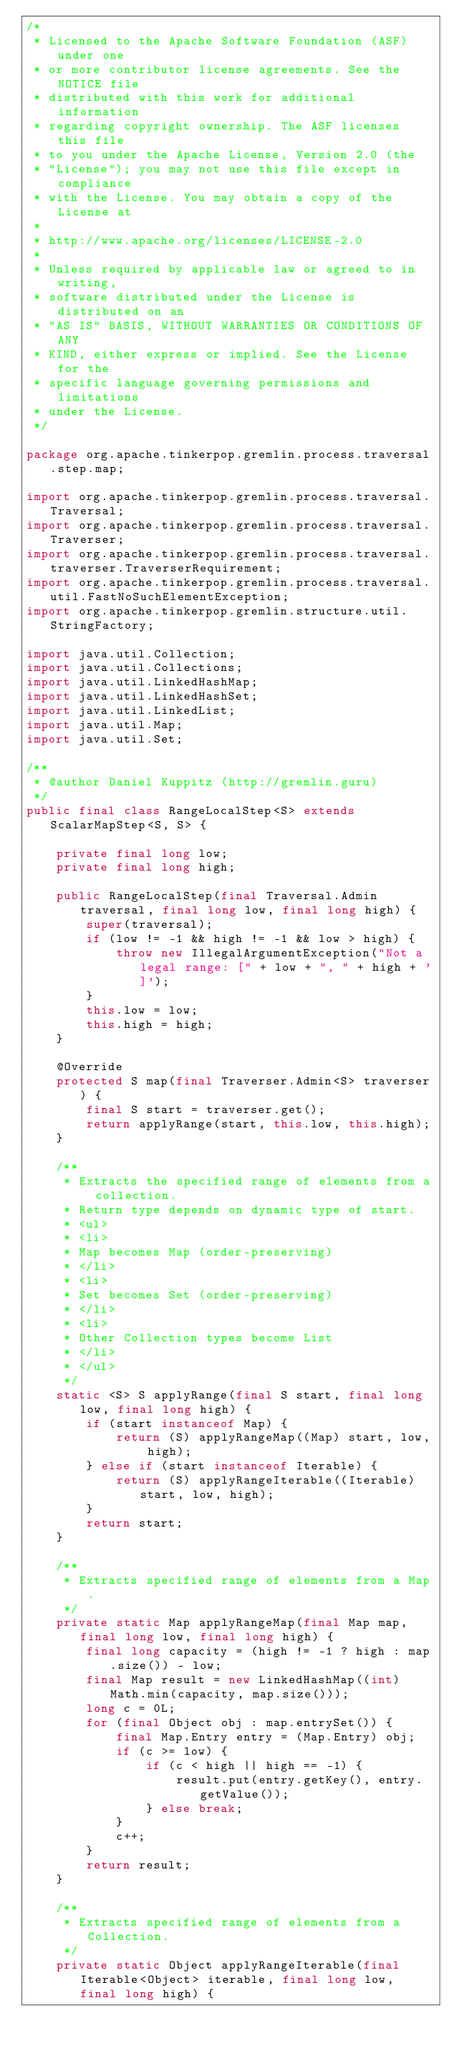Convert code to text. <code><loc_0><loc_0><loc_500><loc_500><_Java_>/*
 * Licensed to the Apache Software Foundation (ASF) under one
 * or more contributor license agreements. See the NOTICE file
 * distributed with this work for additional information
 * regarding copyright ownership. The ASF licenses this file
 * to you under the Apache License, Version 2.0 (the
 * "License"); you may not use this file except in compliance
 * with the License. You may obtain a copy of the License at
 *
 * http://www.apache.org/licenses/LICENSE-2.0
 *
 * Unless required by applicable law or agreed to in writing,
 * software distributed under the License is distributed on an
 * "AS IS" BASIS, WITHOUT WARRANTIES OR CONDITIONS OF ANY
 * KIND, either express or implied. See the License for the
 * specific language governing permissions and limitations
 * under the License.
 */

package org.apache.tinkerpop.gremlin.process.traversal.step.map;

import org.apache.tinkerpop.gremlin.process.traversal.Traversal;
import org.apache.tinkerpop.gremlin.process.traversal.Traverser;
import org.apache.tinkerpop.gremlin.process.traversal.traverser.TraverserRequirement;
import org.apache.tinkerpop.gremlin.process.traversal.util.FastNoSuchElementException;
import org.apache.tinkerpop.gremlin.structure.util.StringFactory;

import java.util.Collection;
import java.util.Collections;
import java.util.LinkedHashMap;
import java.util.LinkedHashSet;
import java.util.LinkedList;
import java.util.Map;
import java.util.Set;

/**
 * @author Daniel Kuppitz (http://gremlin.guru)
 */
public final class RangeLocalStep<S> extends ScalarMapStep<S, S> {

    private final long low;
    private final long high;

    public RangeLocalStep(final Traversal.Admin traversal, final long low, final long high) {
        super(traversal);
        if (low != -1 && high != -1 && low > high) {
            throw new IllegalArgumentException("Not a legal range: [" + low + ", " + high + ']');
        }
        this.low = low;
        this.high = high;
    }

    @Override
    protected S map(final Traverser.Admin<S> traverser) {
        final S start = traverser.get();
        return applyRange(start, this.low, this.high);
    }

    /**
     * Extracts the specified range of elements from a collection.
     * Return type depends on dynamic type of start.
     * <ul>
     * <li>
     * Map becomes Map (order-preserving)
     * </li>
     * <li>
     * Set becomes Set (order-preserving)
     * </li>
     * <li>
     * Other Collection types become List
     * </li>
     * </ul>
     */
    static <S> S applyRange(final S start, final long low, final long high) {
        if (start instanceof Map) {
            return (S) applyRangeMap((Map) start, low, high);
        } else if (start instanceof Iterable) {
            return (S) applyRangeIterable((Iterable) start, low, high);
        }
        return start;
    }

    /**
     * Extracts specified range of elements from a Map.
     */
    private static Map applyRangeMap(final Map map, final long low, final long high) {
        final long capacity = (high != -1 ? high : map.size()) - low;
        final Map result = new LinkedHashMap((int) Math.min(capacity, map.size()));
        long c = 0L;
        for (final Object obj : map.entrySet()) {
            final Map.Entry entry = (Map.Entry) obj;
            if (c >= low) {
                if (c < high || high == -1) {
                    result.put(entry.getKey(), entry.getValue());
                } else break;
            }
            c++;
        }
        return result;
    }

    /**
     * Extracts specified range of elements from a Collection.
     */
    private static Object applyRangeIterable(final Iterable<Object> iterable, final long low, final long high) {</code> 